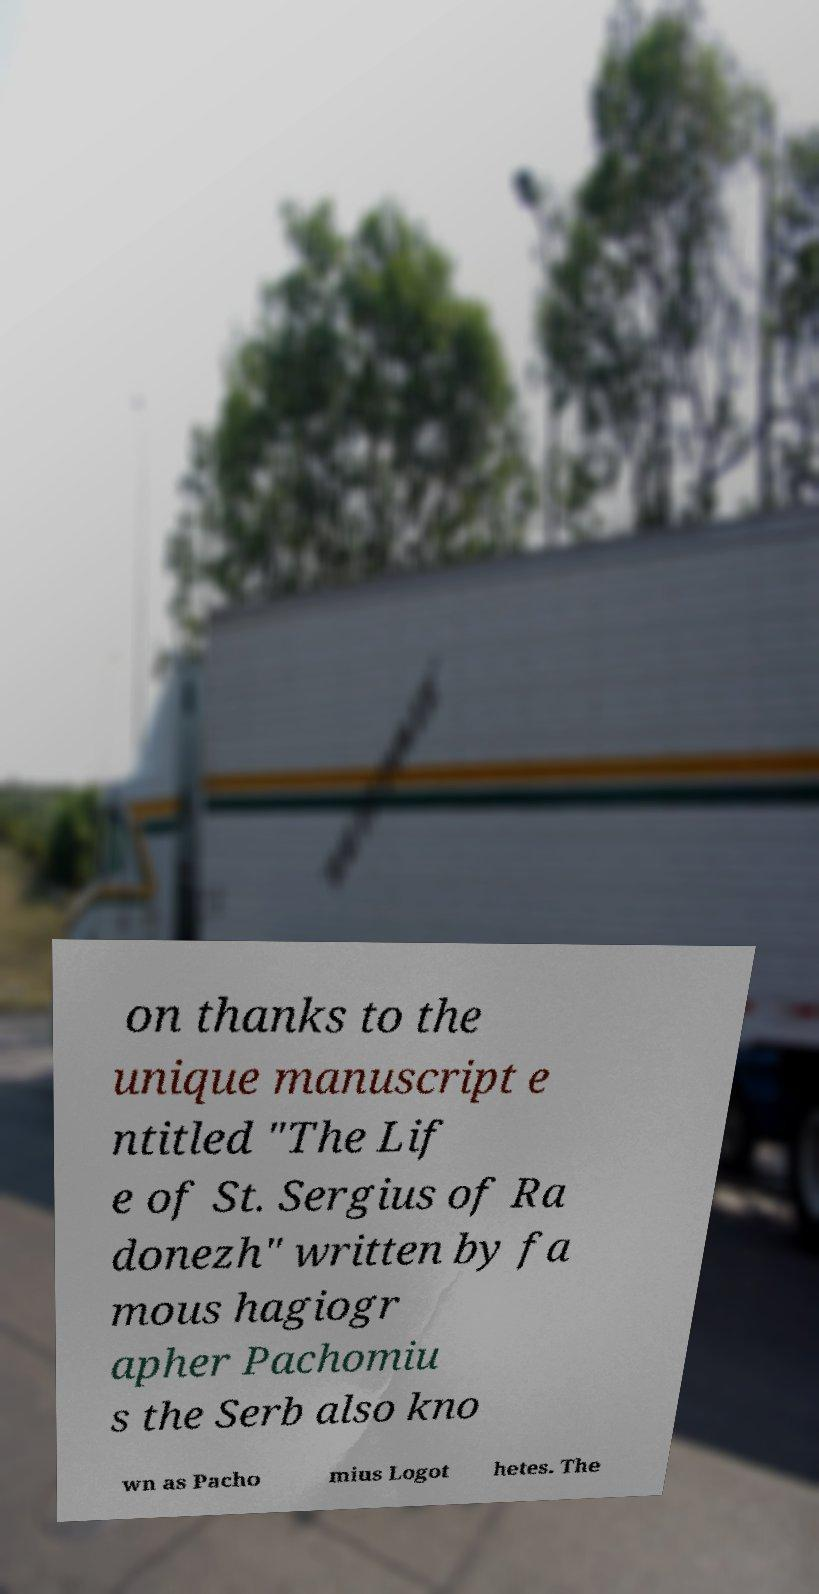I need the written content from this picture converted into text. Can you do that? on thanks to the unique manuscript e ntitled "The Lif e of St. Sergius of Ra donezh" written by fa mous hagiogr apher Pachomiu s the Serb also kno wn as Pacho mius Logot hetes. The 